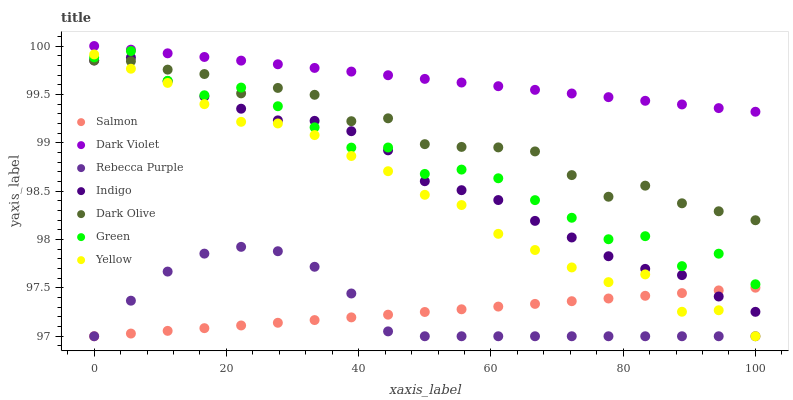Does Salmon have the minimum area under the curve?
Answer yes or no. Yes. Does Dark Violet have the maximum area under the curve?
Answer yes or no. Yes. Does Dark Olive have the minimum area under the curve?
Answer yes or no. No. Does Dark Olive have the maximum area under the curve?
Answer yes or no. No. Is Salmon the smoothest?
Answer yes or no. Yes. Is Green the roughest?
Answer yes or no. Yes. Is Dark Olive the smoothest?
Answer yes or no. No. Is Dark Olive the roughest?
Answer yes or no. No. Does Salmon have the lowest value?
Answer yes or no. Yes. Does Dark Olive have the lowest value?
Answer yes or no. No. Does Dark Violet have the highest value?
Answer yes or no. Yes. Does Dark Olive have the highest value?
Answer yes or no. No. Is Salmon less than Dark Olive?
Answer yes or no. Yes. Is Dark Violet greater than Yellow?
Answer yes or no. Yes. Does Dark Olive intersect Indigo?
Answer yes or no. Yes. Is Dark Olive less than Indigo?
Answer yes or no. No. Is Dark Olive greater than Indigo?
Answer yes or no. No. Does Salmon intersect Dark Olive?
Answer yes or no. No. 